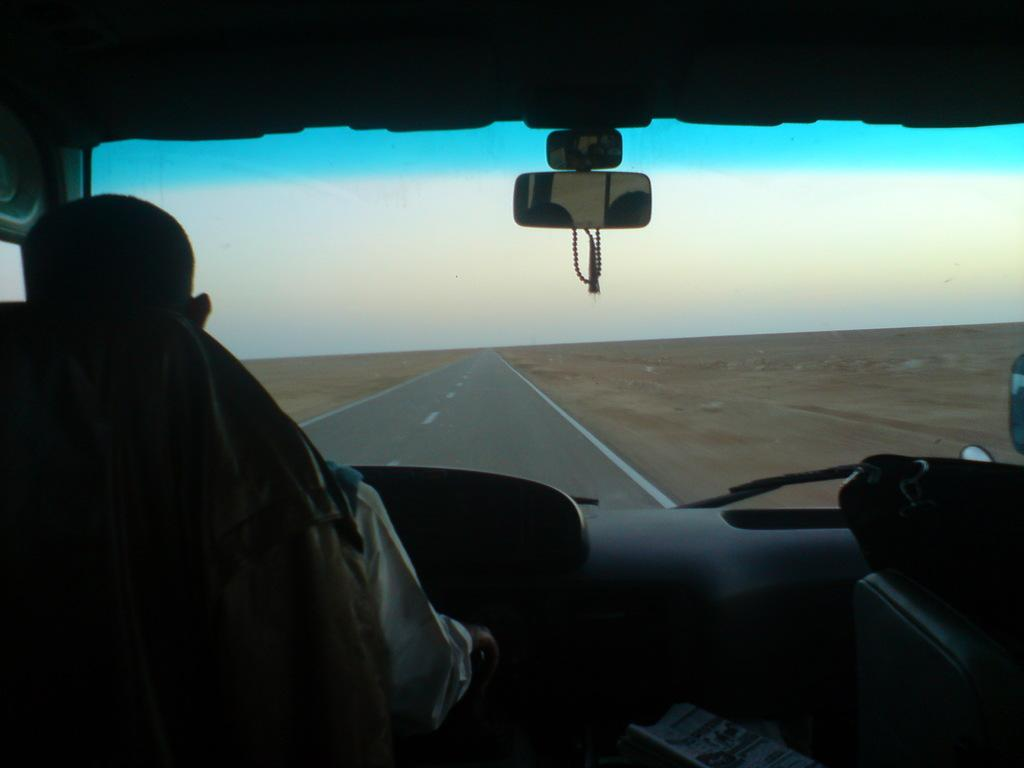What type of view is shown in the image? The image is an inside view of a vehicle. Who is operating the vehicle in the image? There is a man driving the vehicle. What can be seen outside the vehicle in the image? The road is visible in the background. What is visible above the vehicle in the image? The sky is visible at the top of the image. What type of prose is being recited by the man in the image? There is no indication in the image that the man is reciting any prose. 